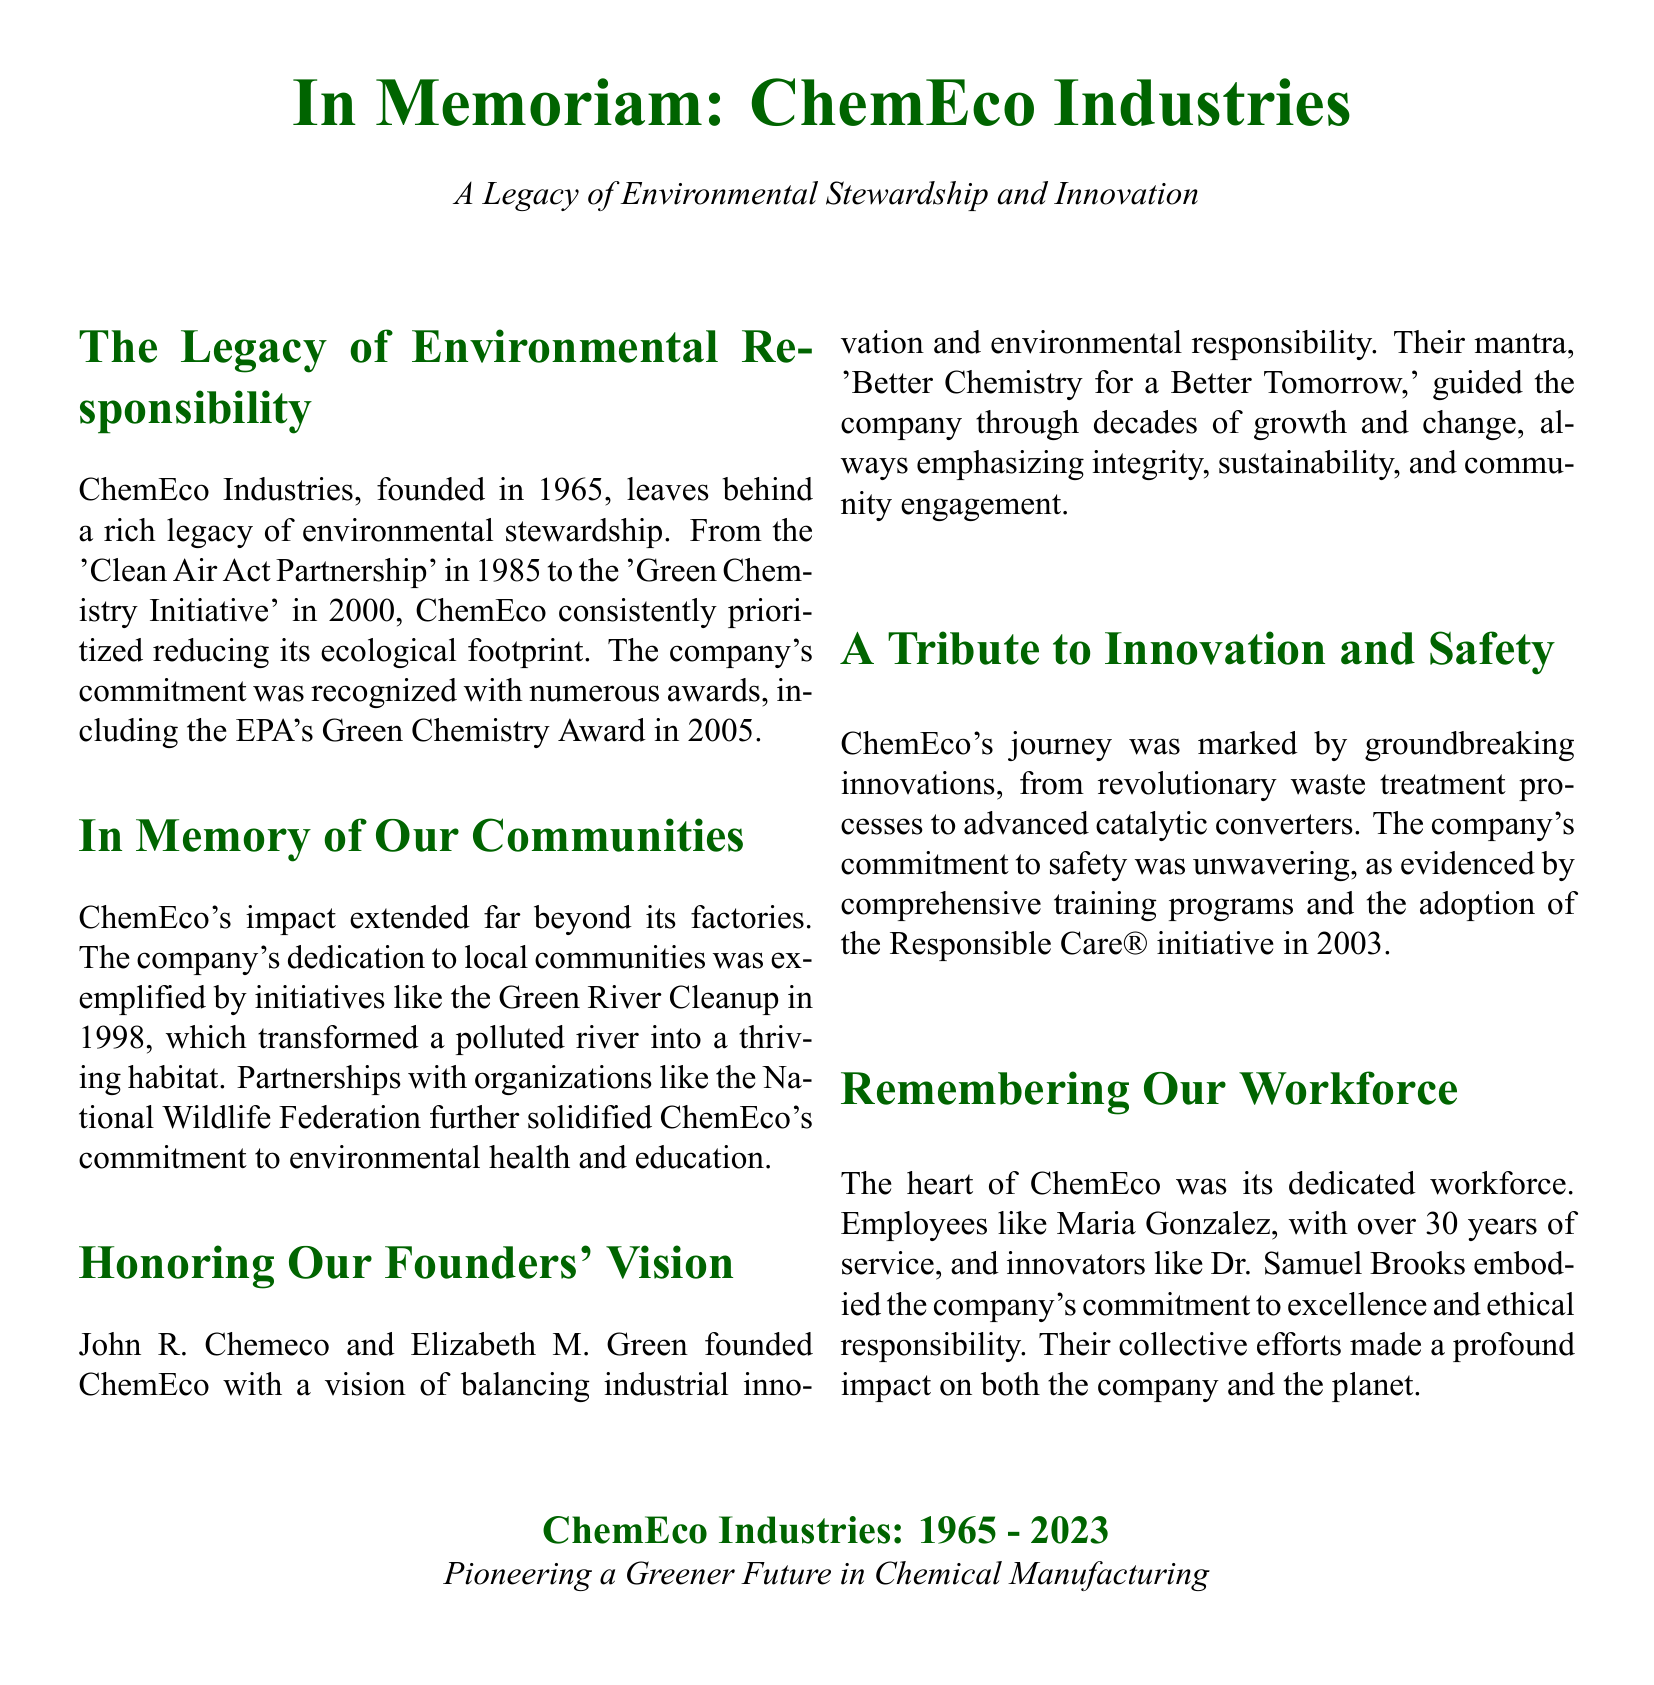What year was ChemEco founded? The document states that ChemEco Industries was founded in 1965.
Answer: 1965 What award did ChemEco receive in 2005? According to the document, ChemEco received the EPA's Green Chemistry Award in 2005.
Answer: EPA's Green Chemistry Award What environmental project did ChemEco undertake in 1998? The document mentions the Green River Cleanup as an initiative by ChemEco in 1998.
Answer: Green River Cleanup Who were the founders of ChemEco? The obituary names John R. Chemeco and Elizabeth M. Green as the founders of ChemEco.
Answer: John R. Chemeco and Elizabeth M. Green What phrase encapsulated ChemEco's founding vision? The document quotes their mantra as "Better Chemistry for a Better Tomorrow."
Answer: Better Chemistry for a Better Tomorrow What initiative was adopted by ChemEco in 2003 to enhance safety? The document mentions that ChemEco adopted the Responsible Care® initiative in 2003.
Answer: Responsible Care® How long did Maria Gonzalez serve at ChemEco? According to the document, Maria Gonzalez had over 30 years of service at ChemEco.
Answer: over 30 years What does the document emphasize about ChemEco's workforce? The document highlights the dedication and contributions of its employees in building a responsible corporate culture.
Answer: dedication and contributions What is the main theme of the obituary? The main theme of the obituary is ChemEco's legacy in environmental stewardship and innovation.
Answer: environmental stewardship and innovation 